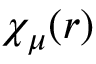Convert formula to latex. <formula><loc_0><loc_0><loc_500><loc_500>\chi _ { \mu } ( r )</formula> 